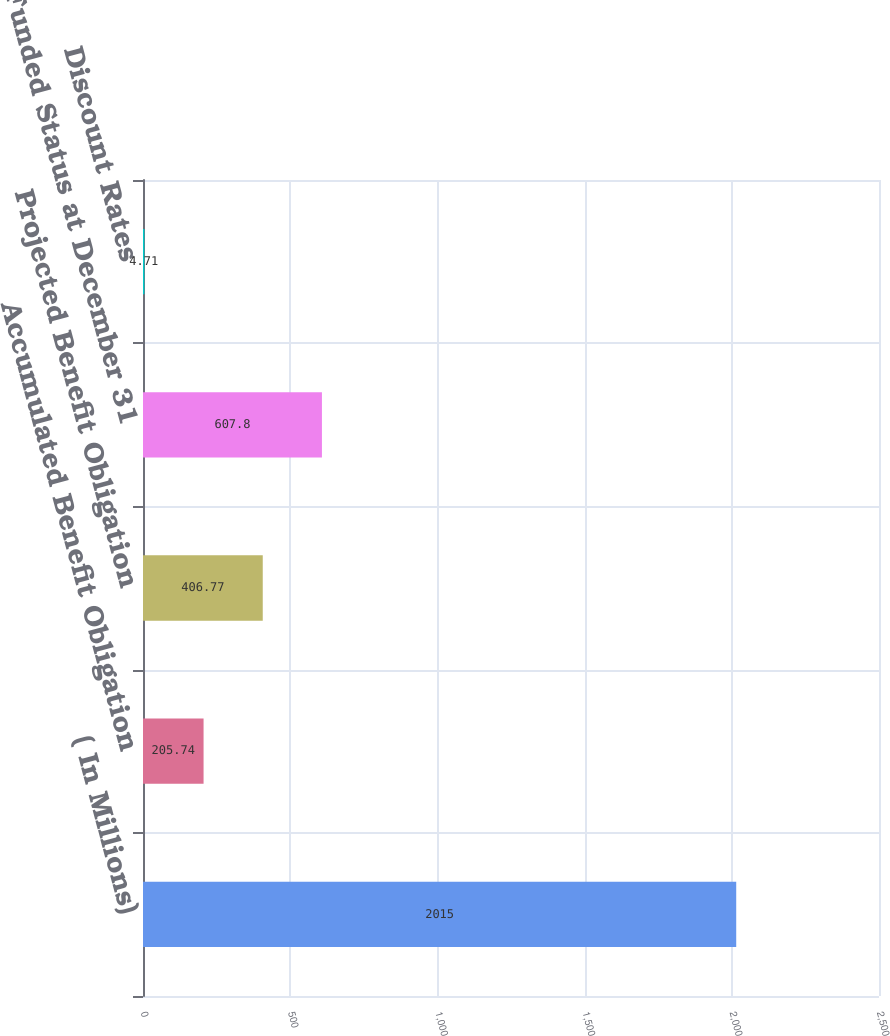Convert chart to OTSL. <chart><loc_0><loc_0><loc_500><loc_500><bar_chart><fcel>( In Millions)<fcel>Accumulated Benefit Obligation<fcel>Projected Benefit Obligation<fcel>Funded Status at December 31<fcel>Discount Rates<nl><fcel>2015<fcel>205.74<fcel>406.77<fcel>607.8<fcel>4.71<nl></chart> 